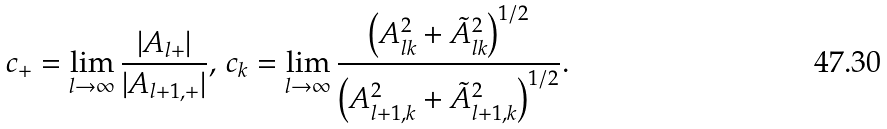<formula> <loc_0><loc_0><loc_500><loc_500>c _ { + } = \lim _ { l \rightarrow \infty } \frac { | A _ { l + } | } { | A _ { l + 1 , + } | } , \, c _ { k } = \lim _ { l \rightarrow \infty } \frac { \left ( A _ { l k } ^ { 2 } + \tilde { A } _ { l k } ^ { 2 } \right ) ^ { 1 / 2 } } { \left ( A _ { l + 1 , k } ^ { 2 } + \tilde { A } _ { l + 1 , k } ^ { 2 } \right ) ^ { 1 / 2 } } .</formula> 